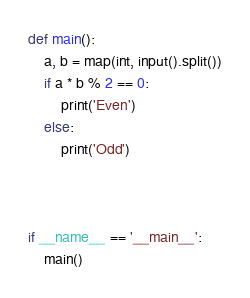Convert code to text. <code><loc_0><loc_0><loc_500><loc_500><_Python_>


def main():
    a, b = map(int, input().split())
    if a * b % 2 == 0:
        print('Even')
    else:
        print('Odd')



if __name__ == '__main__':
    main()
</code> 